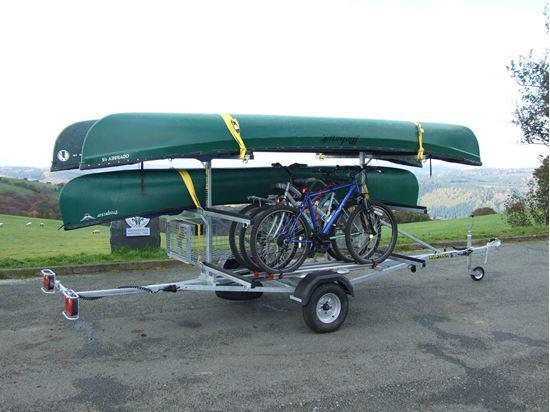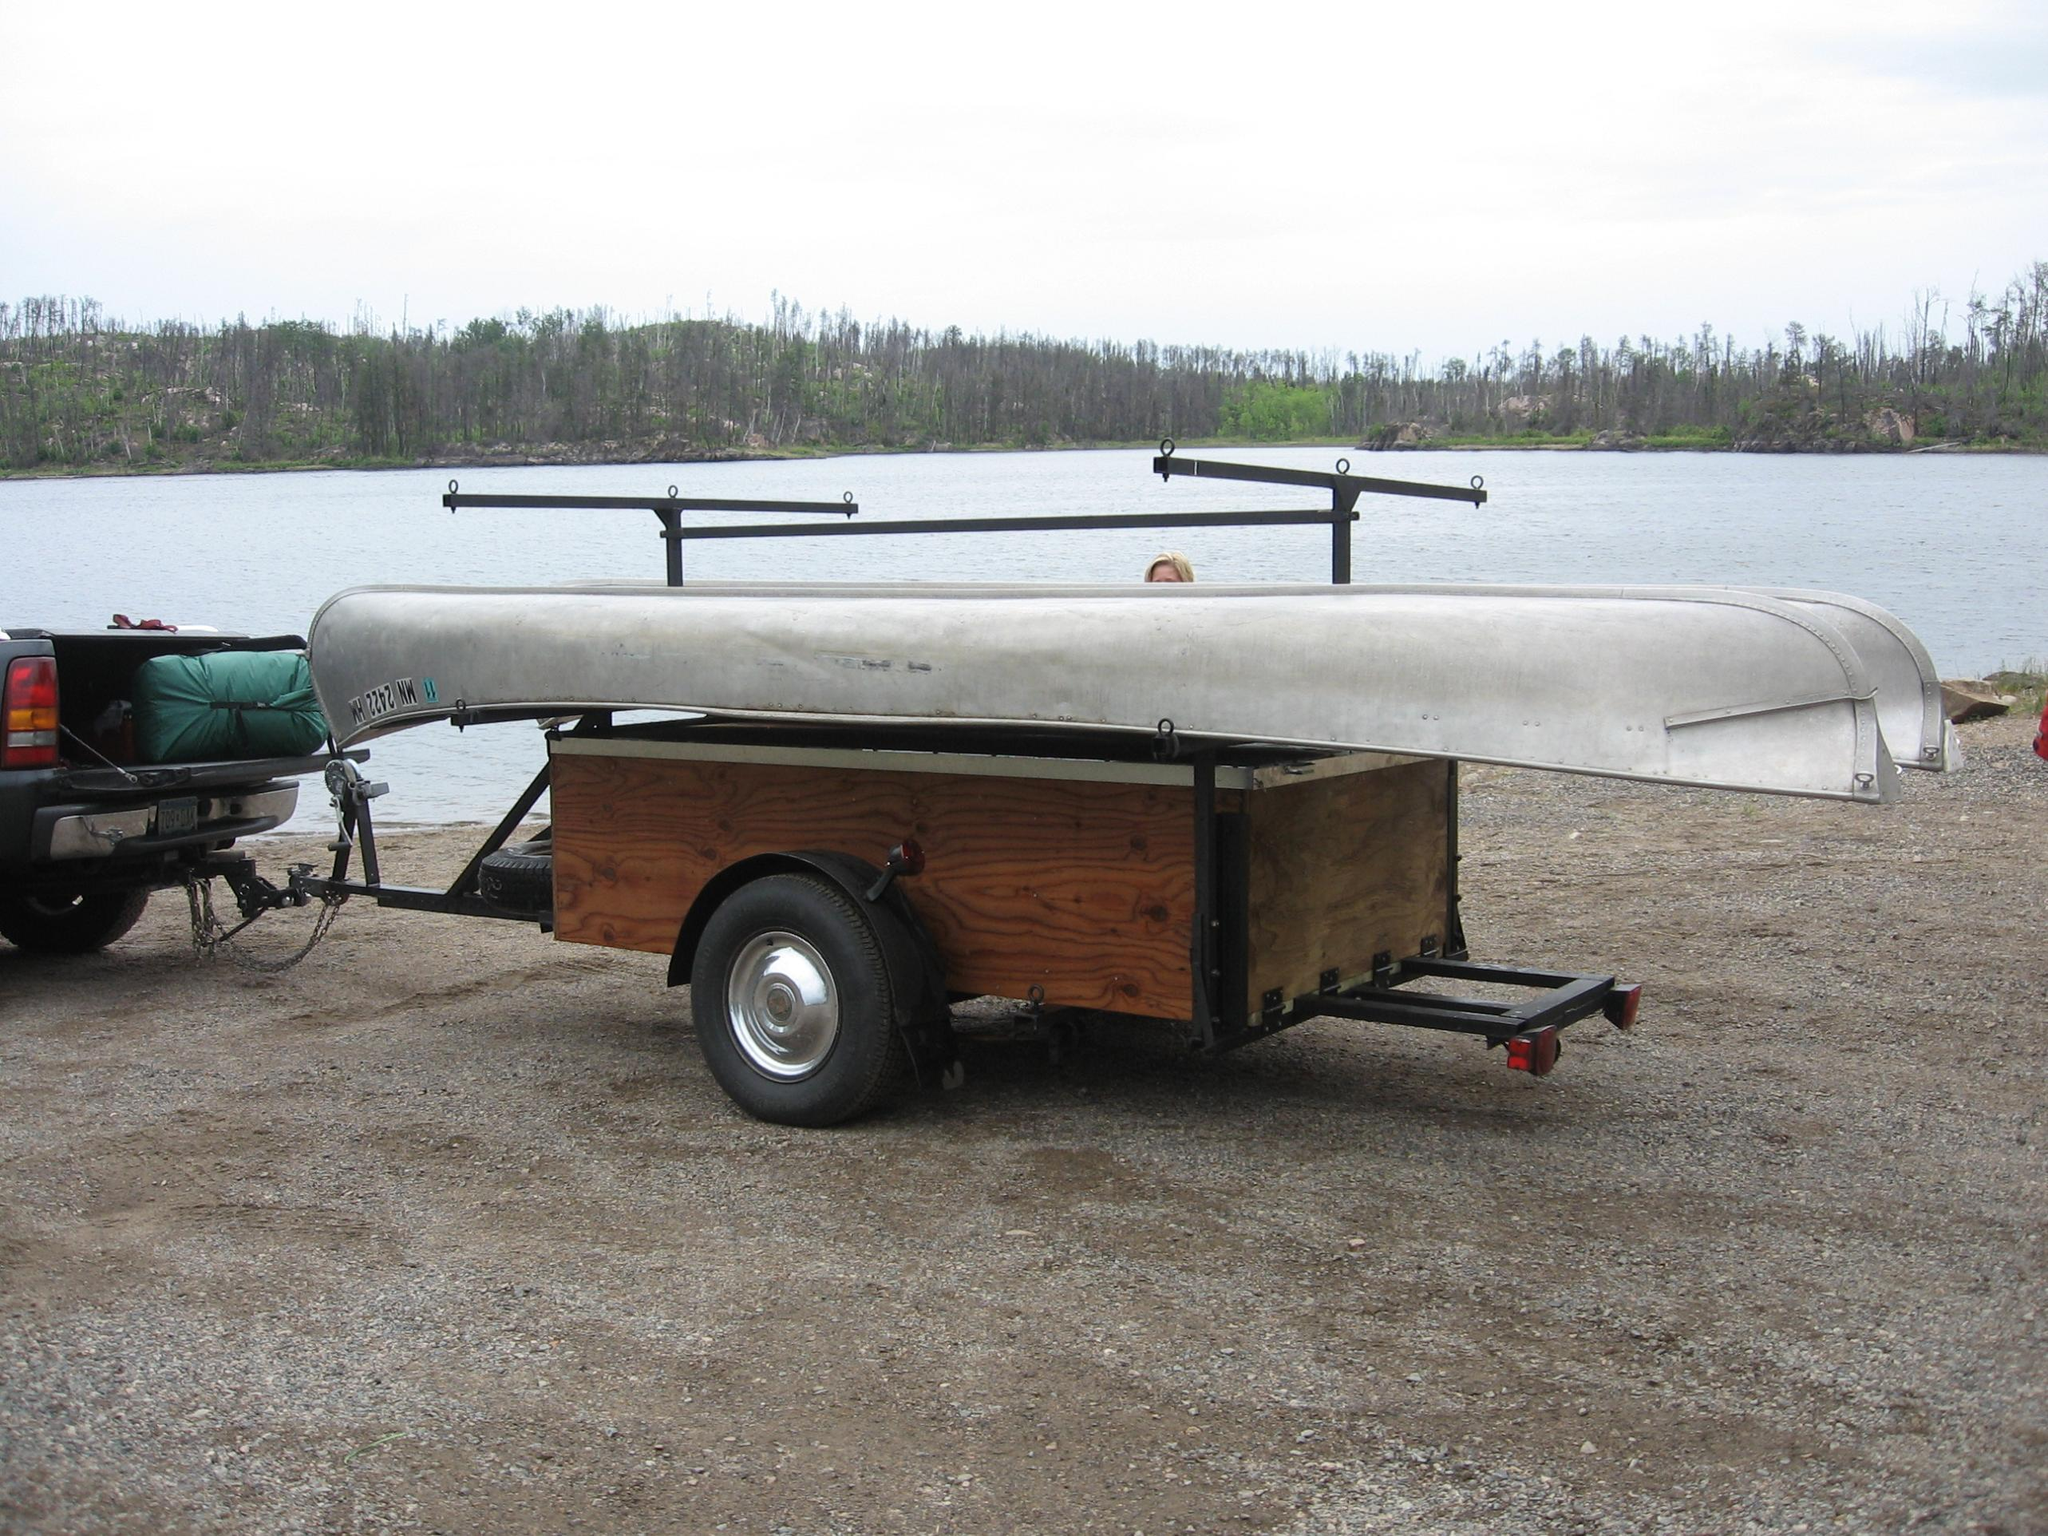The first image is the image on the left, the second image is the image on the right. Given the left and right images, does the statement "Two canoes of the same color are on a trailer." hold true? Answer yes or no. Yes. The first image is the image on the left, the second image is the image on the right. Given the left and right images, does the statement "One trailer is loaded with at least one boat, while the other is loaded with at least one boat plus other riding vehicles." hold true? Answer yes or no. Yes. 